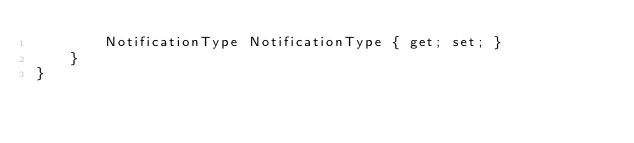Convert code to text. <code><loc_0><loc_0><loc_500><loc_500><_C#_>        NotificationType NotificationType { get; set; }
    }
}</code> 